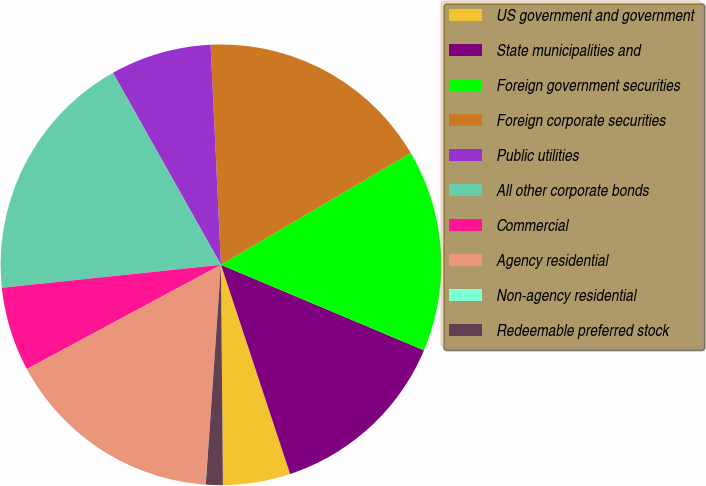Convert chart. <chart><loc_0><loc_0><loc_500><loc_500><pie_chart><fcel>US government and government<fcel>State municipalities and<fcel>Foreign government securities<fcel>Foreign corporate securities<fcel>Public utilities<fcel>All other corporate bonds<fcel>Commercial<fcel>Agency residential<fcel>Non-agency residential<fcel>Redeemable preferred stock<nl><fcel>4.94%<fcel>13.58%<fcel>14.81%<fcel>17.28%<fcel>7.41%<fcel>18.51%<fcel>6.18%<fcel>16.05%<fcel>0.01%<fcel>1.24%<nl></chart> 